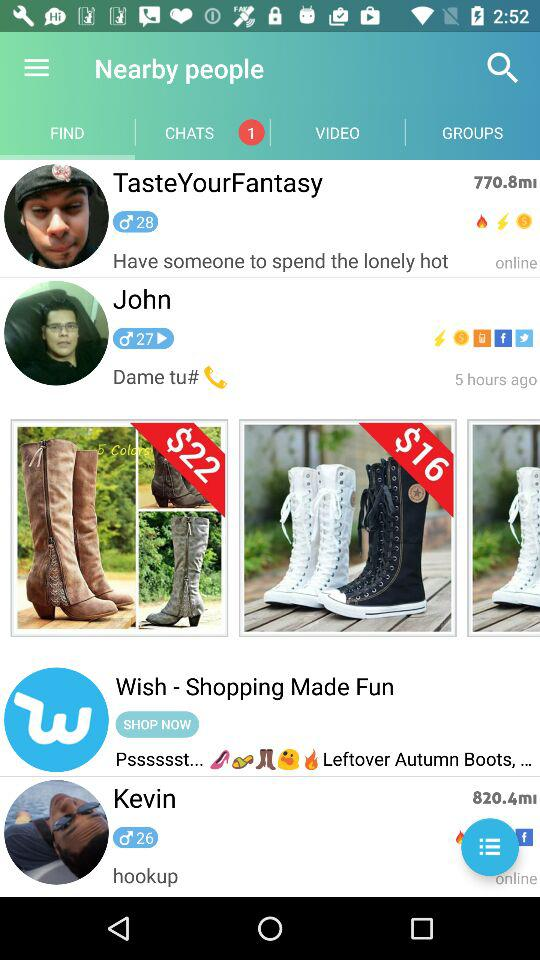How many hours ago was John online? John was online 5 hours ago. 